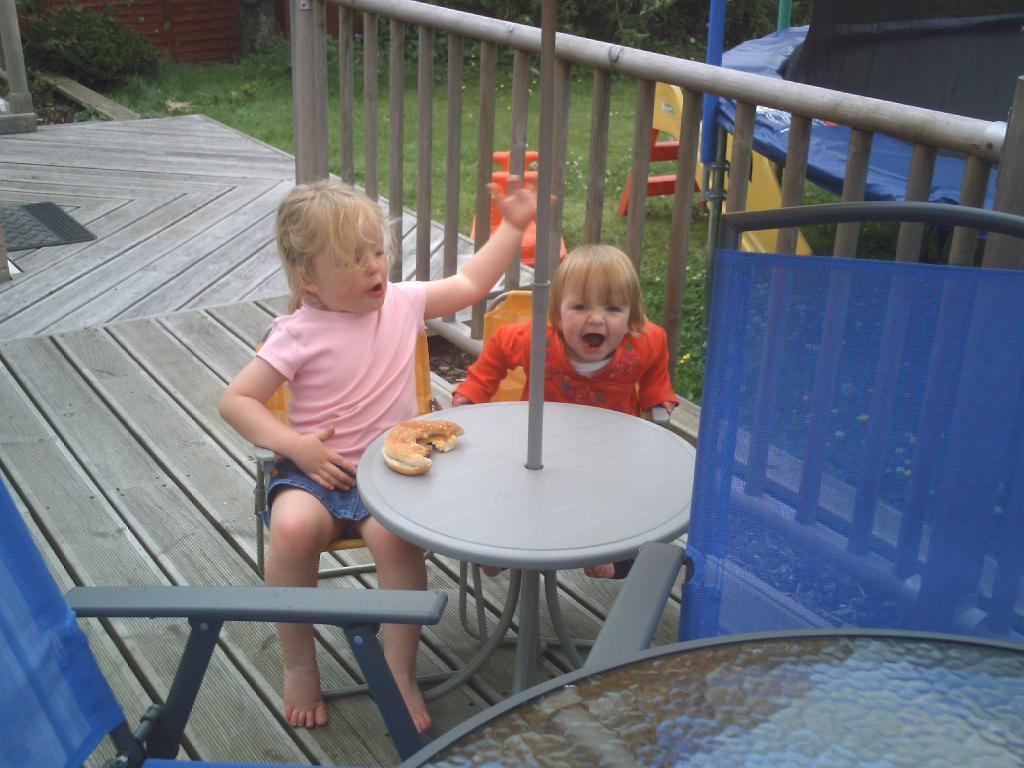How many kids are in the image? There are two kids in the image. What are the kids doing in the image? The kids are sitting on chairs. Where are the chairs located in relation to the table? The chairs are in front of a table. What can be found on the table? There is a food item on the table. What can be seen in the background of the image? There is a railing, a trampoline, a slide, and grass in the background. Is there a river flowing through the background of the image? No, there is no river visible in the image. The background features a railing, a trampoline, a slide, and grass, but no river. 